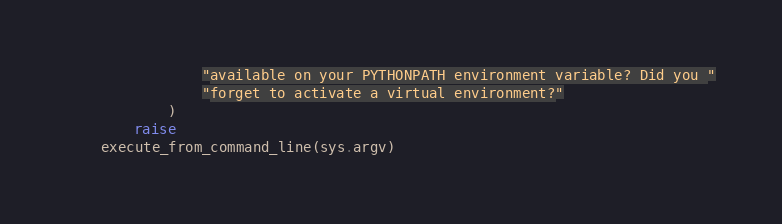<code> <loc_0><loc_0><loc_500><loc_500><_Python_>                "available on your PYTHONPATH environment variable? Did you "
                "forget to activate a virtual environment?"
            )
        raise
    execute_from_command_line(sys.argv)
</code> 